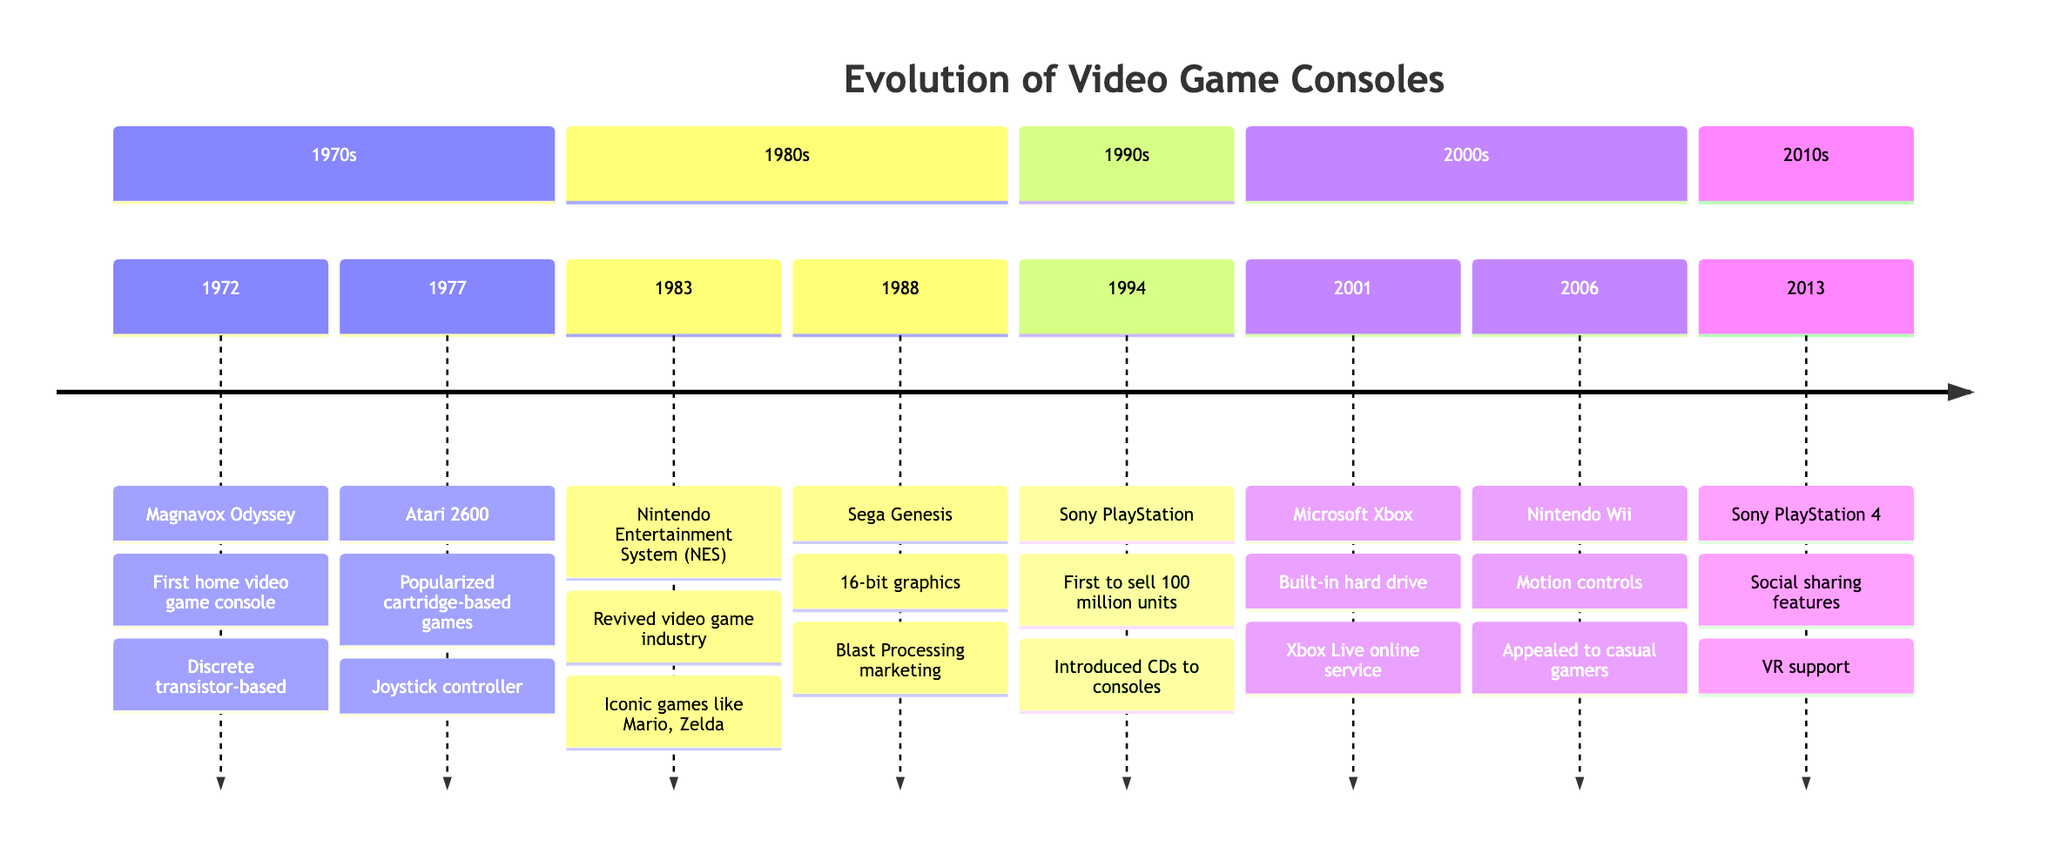What was the first home video game console? According to the timeline, the first home video game console listed is the Magnavox Odyssey, released in 1972.
Answer: Magnavox Odyssey Which console was the first to sell 100 million units? The diagram indicates that the Sony PlayStation, released in 1994, was the first console to sell 100 million units.
Answer: Sony PlayStation In which decade was the Nintendo Entertainment System (NES) released? The NES was released in 1983, which places it in the 1980s section of the timeline.
Answer: 1980s How many key features are listed for the Sega Genesis? The diagram states that there are two key features for the Sega Genesis: 16-bit graphics and Blast Processing marketing. Therefore, the count is two.
Answer: 2 What major feature did the Nintendo Wii introduce? The timeline shows that the Nintendo Wii was known for its motion controls, which was a key feature that differentiated it from earlier consoles.
Answer: Motion controls Which video game console had online services? The diagram notes the Microsoft Xbox, released in 2001, as the first console with a built-in hard drive and Xbox Live online service.
Answer: Microsoft Xbox What unique feature did the PlayStation 4 support? The concise answer is that the PlayStation 4, released in 2013, supported VR (virtual reality) technology, which is listed as one of its key features.
Answer: VR support In which year was the Atari 2600 released? According to the timeline, the Atari 2600 was released in 1977, making it easy to find the exact year of its release.
Answer: 1977 Which console debuted with the ability to play games on CDs? The Sony PlayStation, listed in the 1990s section and released in 1994, is highlighted for being the first console to utilize CDs for gaming.
Answer: Sony PlayStation 